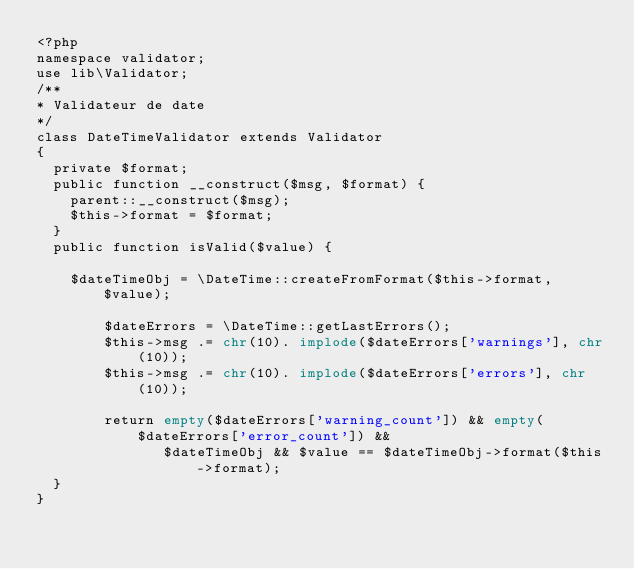Convert code to text. <code><loc_0><loc_0><loc_500><loc_500><_PHP_><?php
namespace validator;
use lib\Validator;
/**
* Validateur de date
*/
class DateTimeValidator extends Validator
{
	private $format;
	public function __construct($msg, $format) {
		parent::__construct($msg);
		$this->format = $format;
	}
	public function isValid($value) {

		$dateTimeObj = \DateTime::createFromFormat($this->format, $value);

        $dateErrors = \DateTime::getLastErrors();
        $this->msg .= chr(10). implode($dateErrors['warnings'], chr(10));
        $this->msg .= chr(10). implode($dateErrors['errors'], chr(10));
     
        return empty($dateErrors['warning_count']) && empty($dateErrors['error_count']) &&
               $dateTimeObj && $value == $dateTimeObj->format($this->format);
	}
}</code> 